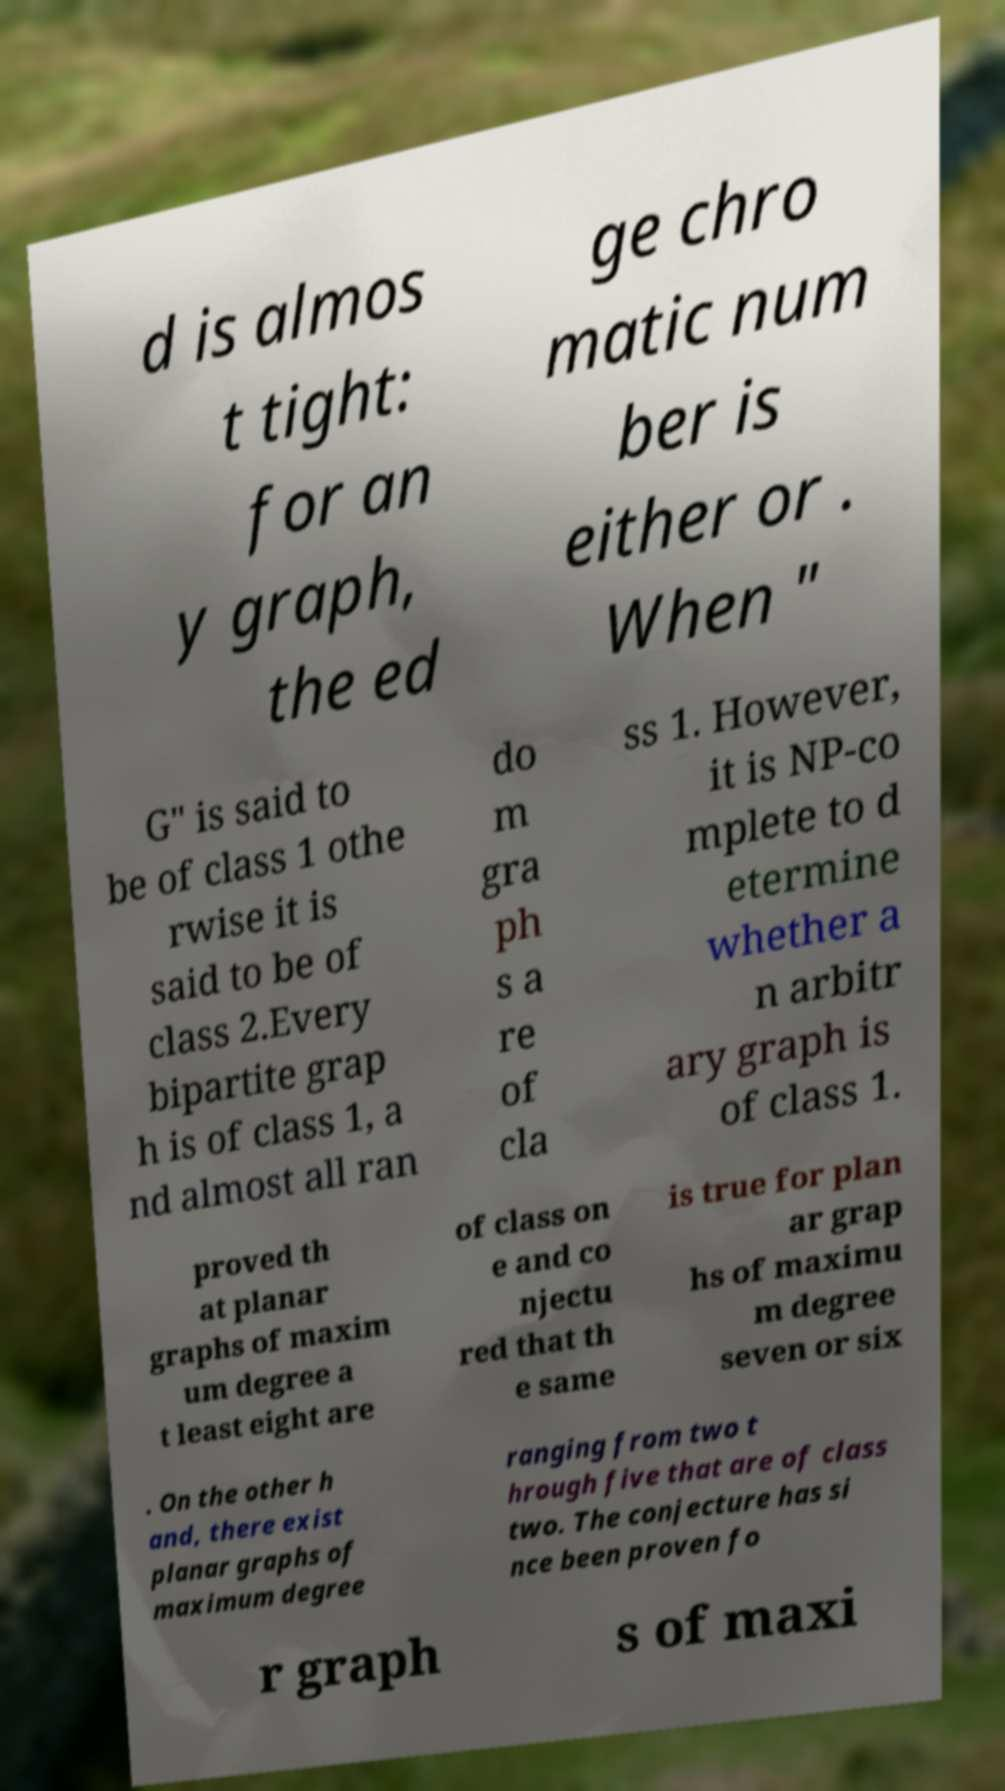Could you extract and type out the text from this image? d is almos t tight: for an y graph, the ed ge chro matic num ber is either or . When " G" is said to be of class 1 othe rwise it is said to be of class 2.Every bipartite grap h is of class 1, a nd almost all ran do m gra ph s a re of cla ss 1. However, it is NP-co mplete to d etermine whether a n arbitr ary graph is of class 1. proved th at planar graphs of maxim um degree a t least eight are of class on e and co njectu red that th e same is true for plan ar grap hs of maximu m degree seven or six . On the other h and, there exist planar graphs of maximum degree ranging from two t hrough five that are of class two. The conjecture has si nce been proven fo r graph s of maxi 